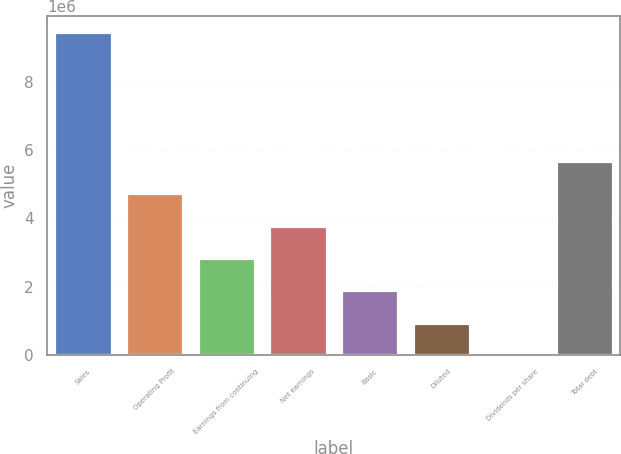Convert chart. <chart><loc_0><loc_0><loc_500><loc_500><bar_chart><fcel>Sales<fcel>Operating Profit<fcel>Earnings from continuing<fcel>Net earnings<fcel>Basic<fcel>Diluted<fcel>Dividends per share<fcel>Total debt<nl><fcel>9.46606e+06<fcel>4.73303e+06<fcel>2.83982e+06<fcel>3.78642e+06<fcel>1.89321e+06<fcel>946606<fcel>0.08<fcel>5.67963e+06<nl></chart> 